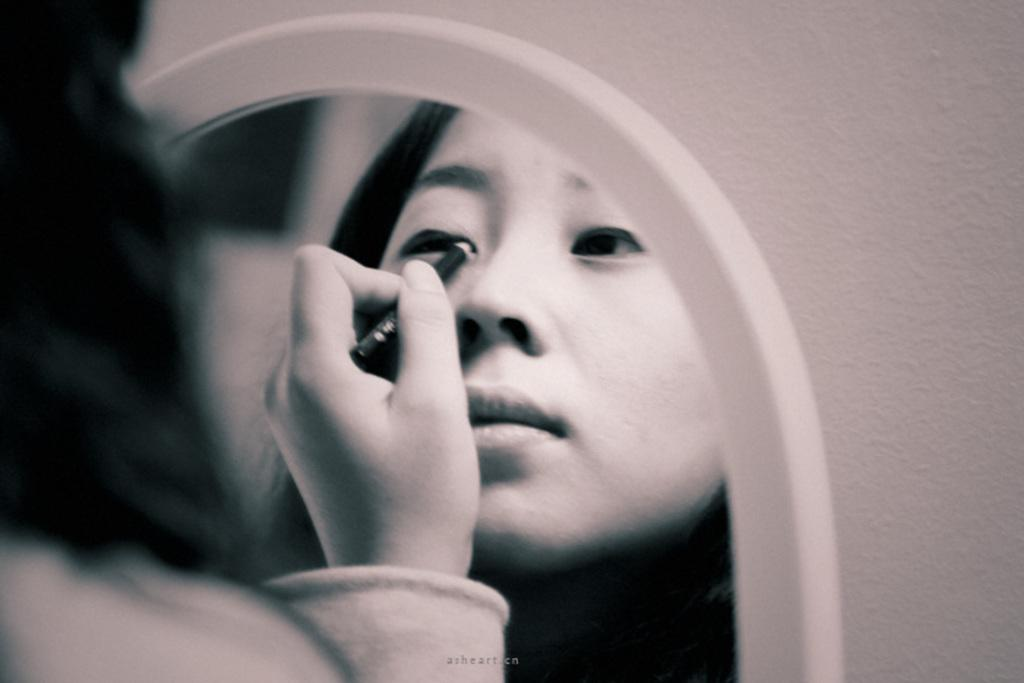Who is the main subject in the image? There is a lady in the image. What is the lady holding in the image? The lady is holding a mirror. What is the lady's reflection doing in the mirror? The lady's reflection in the mirror is holding a pencil near her eye. What type of snow can be seen on the lady's face in the image? There is no snow present on the lady's face in the image. 